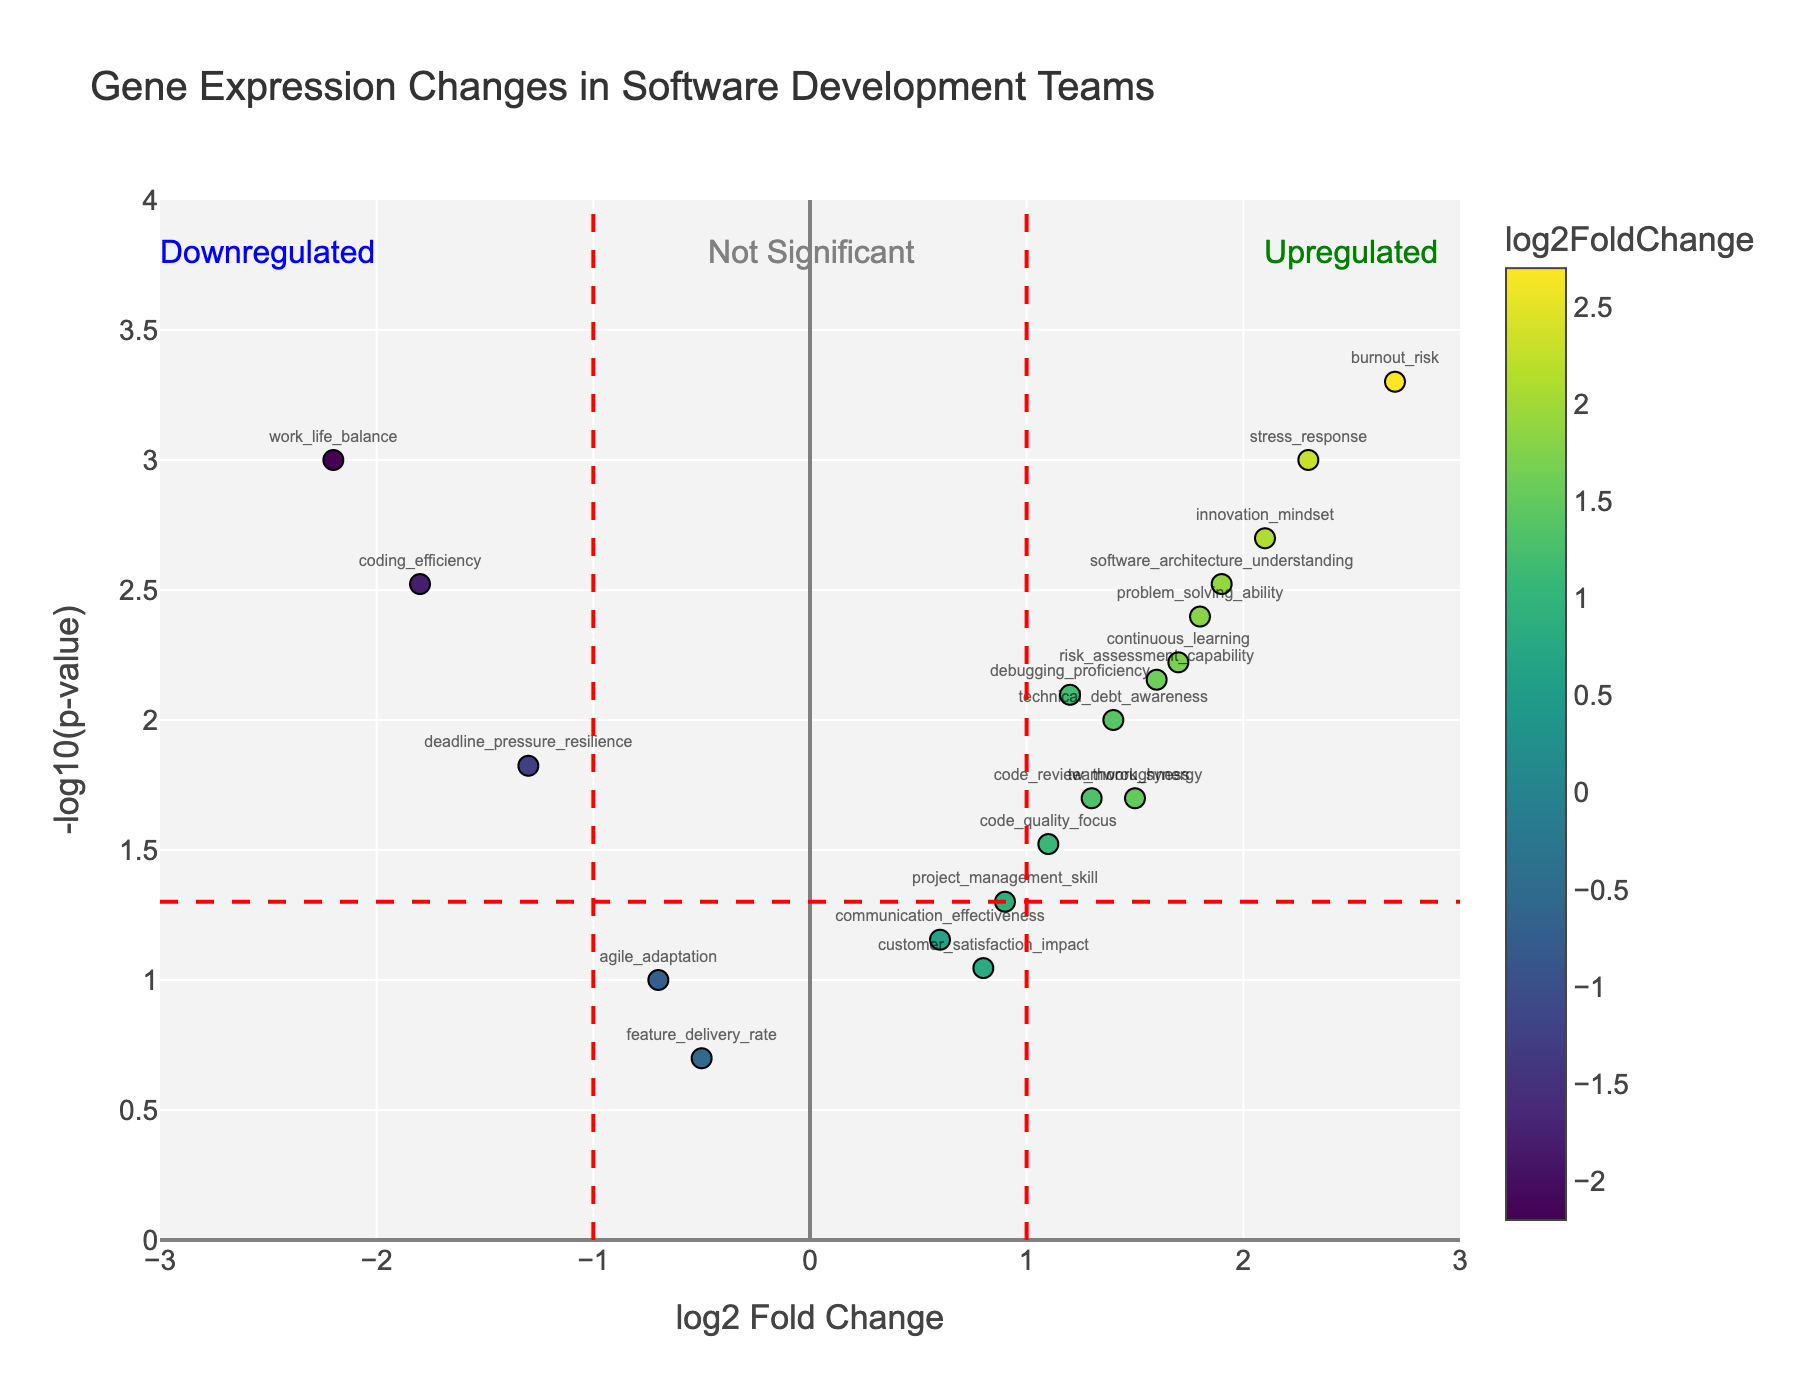What is the title of the figure? The title of the figure is displayed at the top and reads "Gene Expression Changes in Software Development Teams".
Answer: Gene Expression Changes in Software Development Teams What are the labels for the x-axis and y-axis? The x-axis is labeled "log2 Fold Change" and the y-axis is labeled "-log10(p-value)".
Answer: log2 Fold Change, -log10(p-value) How many genes are labeled as significant (p-value < 0.05)? To find the number of genes labeled as significant, check how many points are above the horizontal red dashed line, indicating -log10(0.05).
Answer: 15 Which gene shows the highest log2FoldChange? Look at the gene point with the furthest right position along the x-axis. The gene showing the highest log2FoldChange is around 2.7.
Answer: burnout_risk Is "coding_efficiency" upregulated or downregulated and what is its p-value? Find the "coding_efficiency" point on the plot, which is on the left side indicating a negative log2FoldChange, making it downregulated. Its p-value is revealed by its y-axis value, close to 3 (-log10(0.003)).
Answer: Downregulated, 0.003 Which genes have a p-value of exactly 0.001? Identify the points on the plot that align with the y-axis value of -log10(0.001), approximately 3.
Answer: stress_response, work_life_balance What is the approximate log2FoldChange and p-value for "continuous_learning"? Locate "continuous_learning" on the plot. It appears around 1.7 on the x-axis and approximately 0.006 on the y-axis, corresponding to -log10.
Answer: log2FoldChange: 1.7, p-value: 0.006 How many genes are upregulated with a log2FoldChange greater than 1 and are statistically significant? Count the genes above the horizontal red dashed line and to the right of the vertical red dashed line at 1.
Answer: 7 Which gene has a higher impact, "innovation_mindset" or "software_architecture_understanding", based on their log2FoldChange and p-values? Compare both gene positions on the plot. "innovation_mindset" has a log2FoldChange around 2.1 and a p-value close to 0.002, while "software_architecture_understanding" has a log2FoldChange around 1.9 and a p-value of 0.003. Both log2FoldChange and p-value indicate a higher impact for "innovation_mindset".
Answer: innovation_mindset Which gene has the highest p-value in the plot? The gene closest to the x-axis at the lowest -log10(p-value) indicates the highest p-value. Genes with p-value around 0.2 have -log10(p-value) close to 0.7.
Answer: feature_delivery_rate 